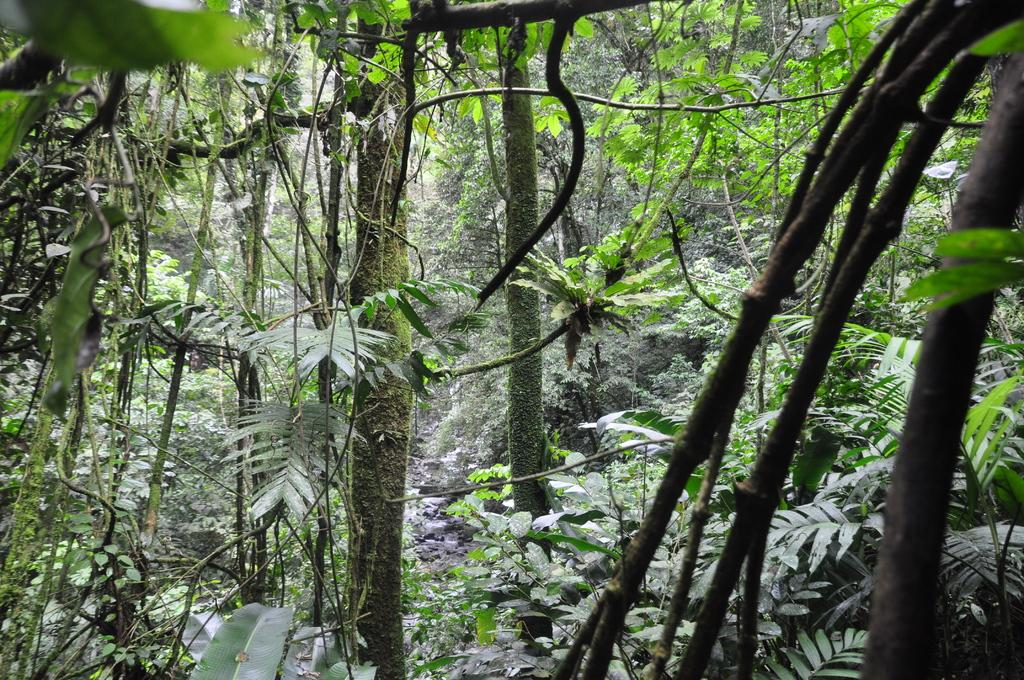Where was the image taken? The image was taken in a forest. What type of vegetation can be seen in the image? There are trees with branches and leaves in the image. What type of ornament is hanging from the tree branches in the image? There is no ornament present in the image; it only features trees with branches and leaves. 